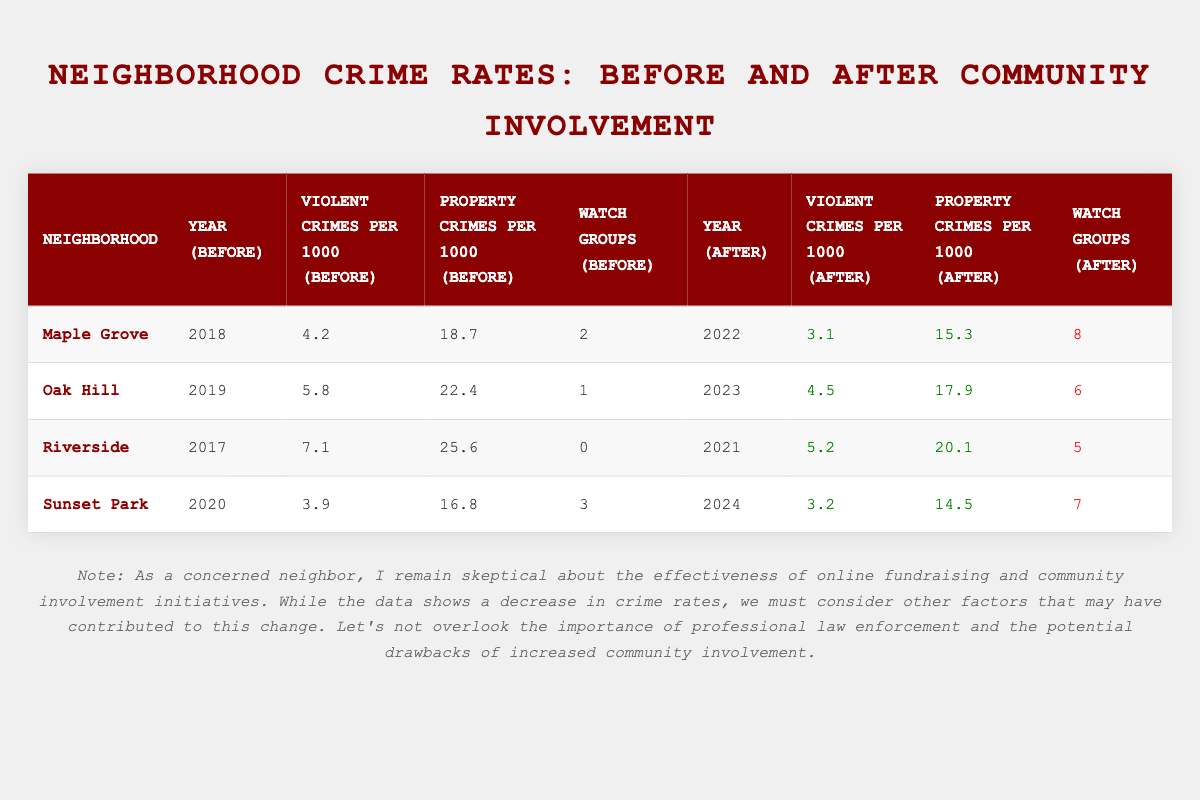What was the violent crime rate in Oak Hill before community involvement? The table indicates that the violent crimes per 1000 in Oak Hill before community involvement was 5.8. This value is provided directly in the corresponding cell of the table.
Answer: 5.8 How many neighborhood watch groups were active in Riverside after community involvement? The table shows that Riverside increased its neighborhood watch groups to 5 after community involvement. This information is readily accessible in the relevant cell.
Answer: 5 What is the percentage decrease in property crimes per 1000 from Maple Grove before and after community involvement? To find the percentage decrease, we first calculate the difference: 18.7 (before) - 15.3 (after) = 3.4. Next, we divide this difference by the original value: 3.4 / 18.7 ≈ 0.1817. Finally, multiply by 100 to get a percentage: 0.1817 * 100 ≈ 18.17%.
Answer: Approximately 18.17% Did Sunset Park experience an increase in the number of neighborhood watch groups from before to after community involvement? By comparing the numbers in the table, Sunset Park had 3 neighborhood watch groups before and increased to 7 after community involvement. This means there was indeed an increase.
Answer: Yes What was the average violent crime rate per 1000 across all neighborhoods after community involvement? We will calculate the average by summing the violent crime rates after involvement: 3.1 (Maple Grove) + 4.5 (Oak Hill) + 5.2 (Riverside) + 3.2 (Sunset Park) = 16.0. Then, divide by the number of neighborhoods, which is 4: 16.0 / 4 = 4.0.
Answer: 4.0 